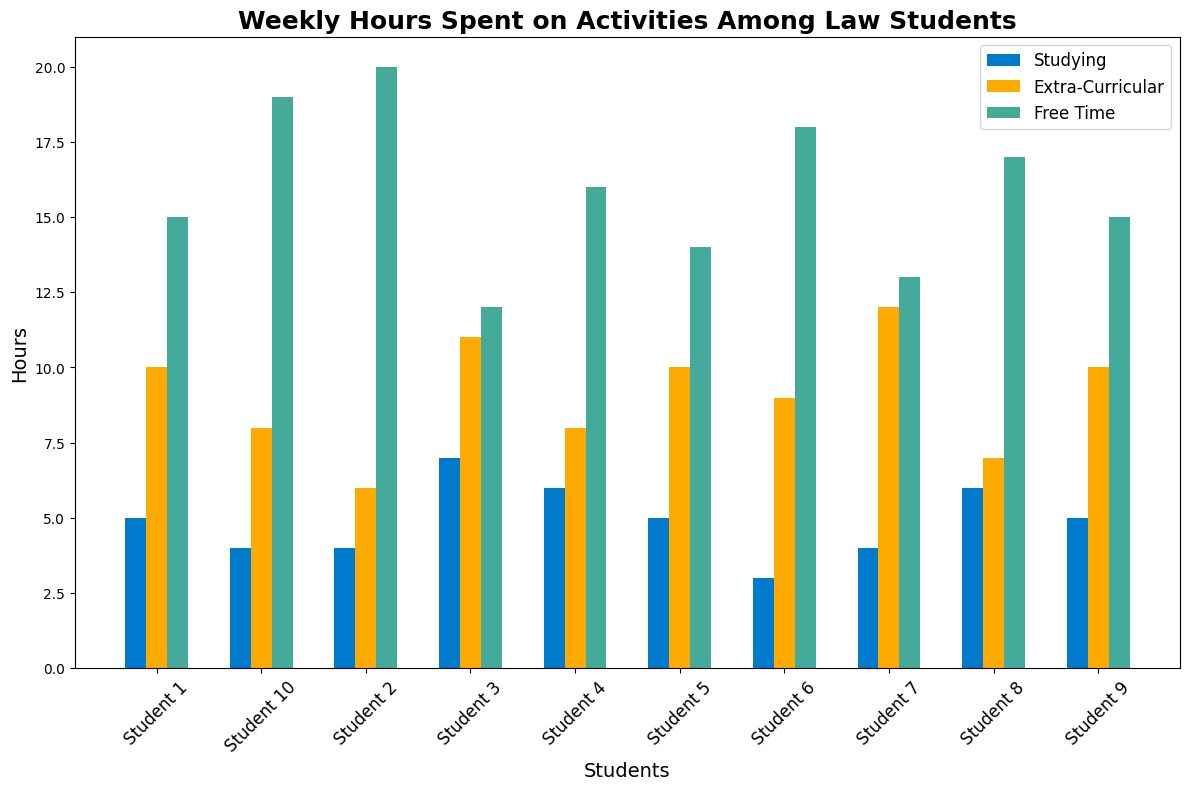Which student spends the most hours on studying? To determine the student who spends the most hours on studying, look at the height of the bars labeled "Studying" for each student. The tallest bar represents the student who spends the most hours. Student 10's bar is the highest under the "Studying" category.
Answer: Student 10 Which activity has the most variation in hours spent among students? To evaluate which activity has the most variation in hours, compare the range of bar heights for each activity across all students. "Studying" has the greatest range, with hours varying from 12 to 20. Compared to "Extra-Curricular" and "Free Time," which have smaller ranges, "Studying" shows the most variation.
Answer: Studying How many more hours does Student 2 spend on studying compared to free time? To find out how many more hours Student 2 spends on studying compared to free time, subtract the hours spent on free time from the hours spent on studying for Student 2. From the figure, Student 2 spends 20 hours on studying and 6 hours on free time. The difference is 20 - 6 = 14.
Answer: 14 Which students spend equal hours on extra-curricular activities and free time? To find the students who spend equal hours on extra-curricular activities and free time, look for bars of equal height in the "Extra-Curricular" and "Free Time" categories for each student. From the plot, Student 1 and Student 9 spend the same amount of time on both activities: 5 hours each.
Answer: Student 1, Student 9 Compare the total hours spent on all activities by Student 3 and Student 7. Who spends more time, and by how much? To compare the total hours, sum the hours spent on all activities for both students. For Student 3: 12 (Studying) + 7 (Extra-Curricular) + 11 (Free Time) = 30. For Student 7: 13 (Studying) + 4 (Extra-Curricular) + 12 (Free Time) = 29. Student 3 spends 30 - 29 = 1 more hour than Student 7.
Answer: Student 3, 1 hour What is the average time spent on extra-curricular activities across all students? To find the average time spent on extra-curricular activities, sum all the hours spent on this activity by each student and divide by the number of students. The sums of hours are 5 + 4 + 7 + 6 + 5 + 3 + 4 + 6 + 5 + 4 = 49. There are 10 students, so the average is 49 / 10 = 4.9 hours.
Answer: 4.9 hours Which activity does Student 8 spend the least amount of time on? To determine the activity where Student 8 spends the least time, compare the student's bar heights in the "Studying", "Extra-Curricular", and "Free Time" categories. The shortest bar is in the "Free Time" category, indicating the lowest hours spent.
Answer: Free Time Is there any student who spends more time on extra-curricular activities than studying? To verify if any student spends more time on extra-curricular activities than studying, compare the bars for "Extra-Curricular" and "Studying" for each student. All students have shorter bars for "Extra-Curricular" compared to "Studying," so no student spends more time on extra-curricular activities than studying.
Answer: No 